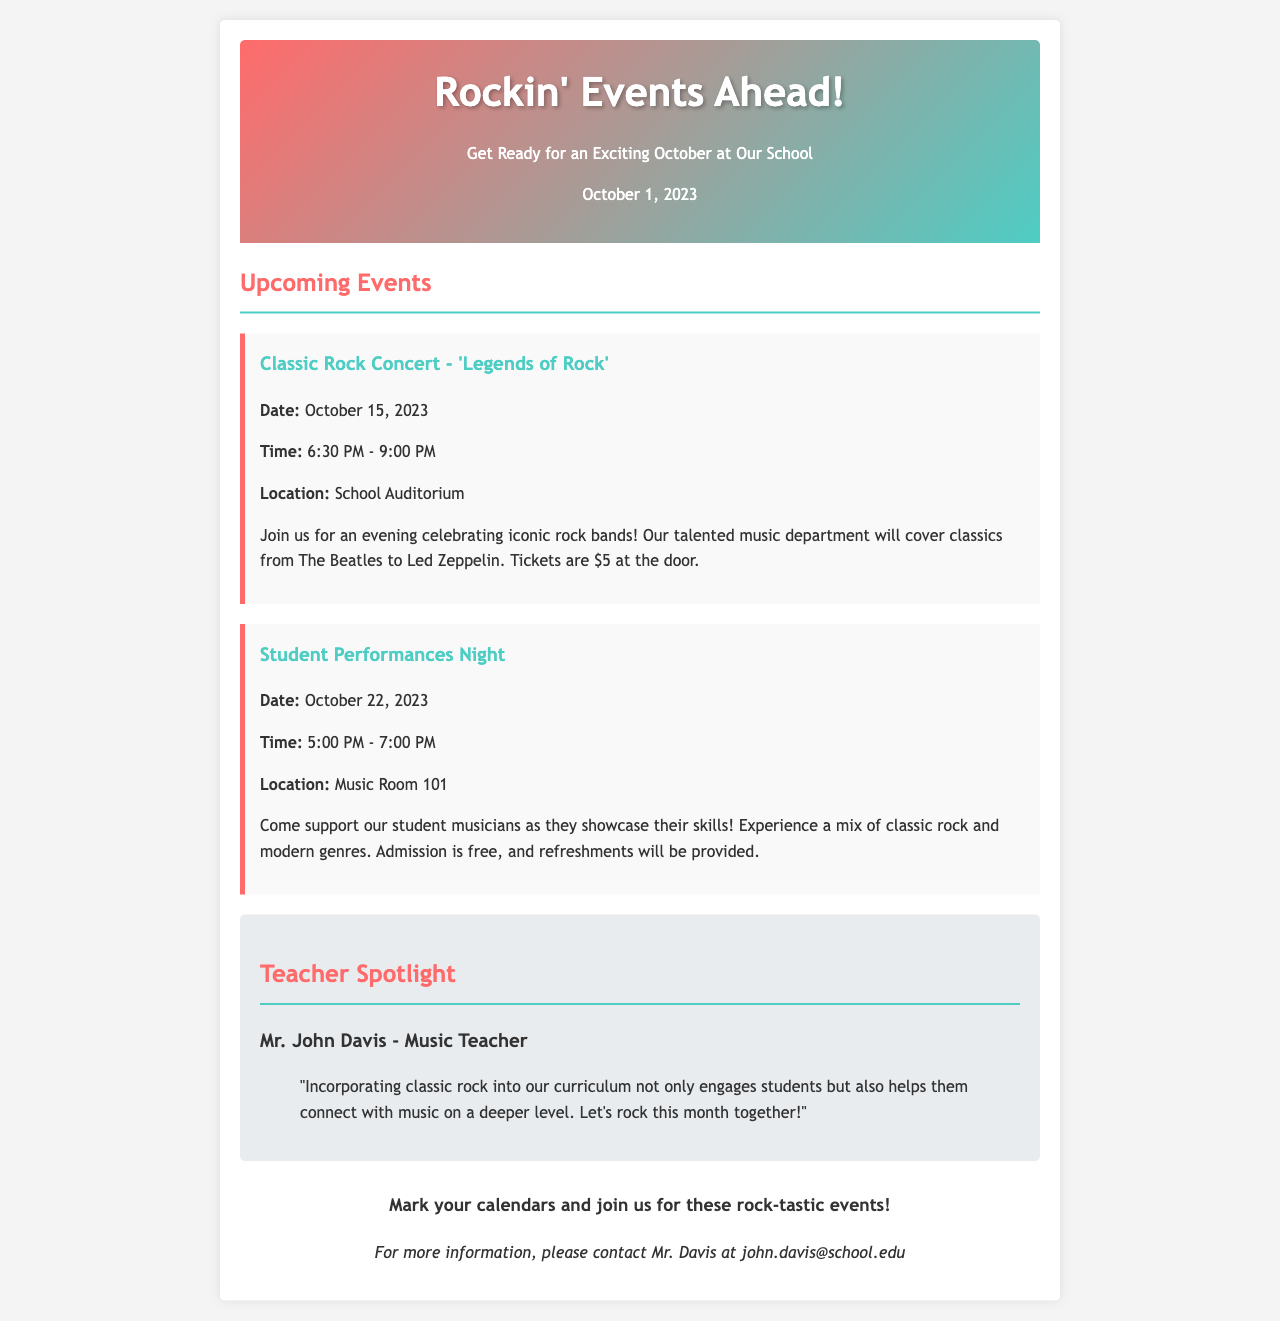What is the title of the concert? The title of the concert is mentioned in the document as "Classic Rock Concert - 'Legends of Rock'."
Answer: Classic Rock Concert - 'Legends of Rock' What is the date of the Student Performances Night? The document specifies the date of the Student Performances Night as October 22, 2023.
Answer: October 22, 2023 How much do tickets cost for the Classic Rock Concert? The document states that tickets for the concert are $5 at the door.
Answer: $5 What is the location of the Classic Rock Concert? The location is provided in the document as the School Auditorium.
Answer: School Auditorium Who is the Teacher Spotlight on? The Teacher Spotlight features Mr. John Davis.
Answer: Mr. John Davis What time does the Classic Rock Concert start? The document indicates that the concert starts at 6:30 PM.
Answer: 6:30 PM What type of music will be featured at the Student Performances Night? The document mentions that students will showcase a mix of classic rock and modern genres.
Answer: Mix of classic rock and modern genres How long will the Student Performances Night last? The duration of the Student Performances Night is stated to be from 5:00 PM to 7:00 PM, which is 2 hours.
Answer: 2 hours What is the purpose of the Student Performances Night? The purpose is outlined as supporting student musicians as they showcase their skills.
Answer: Support student musicians 